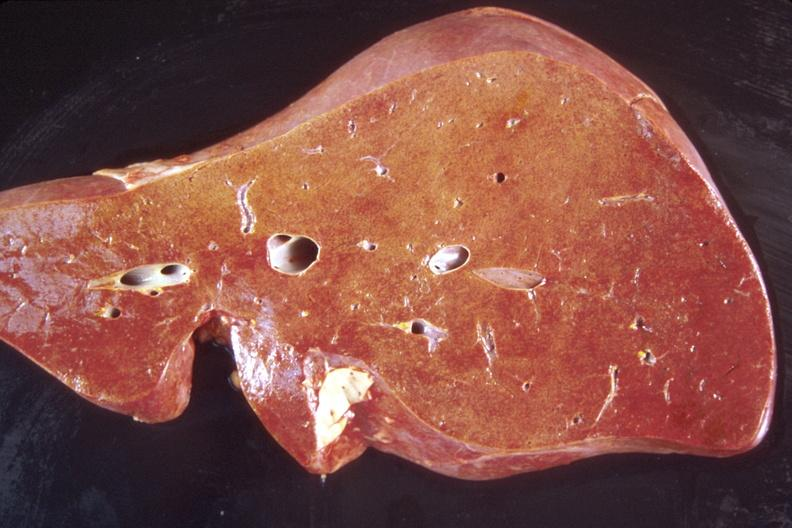what does this image show?
Answer the question using a single word or phrase. Liver 